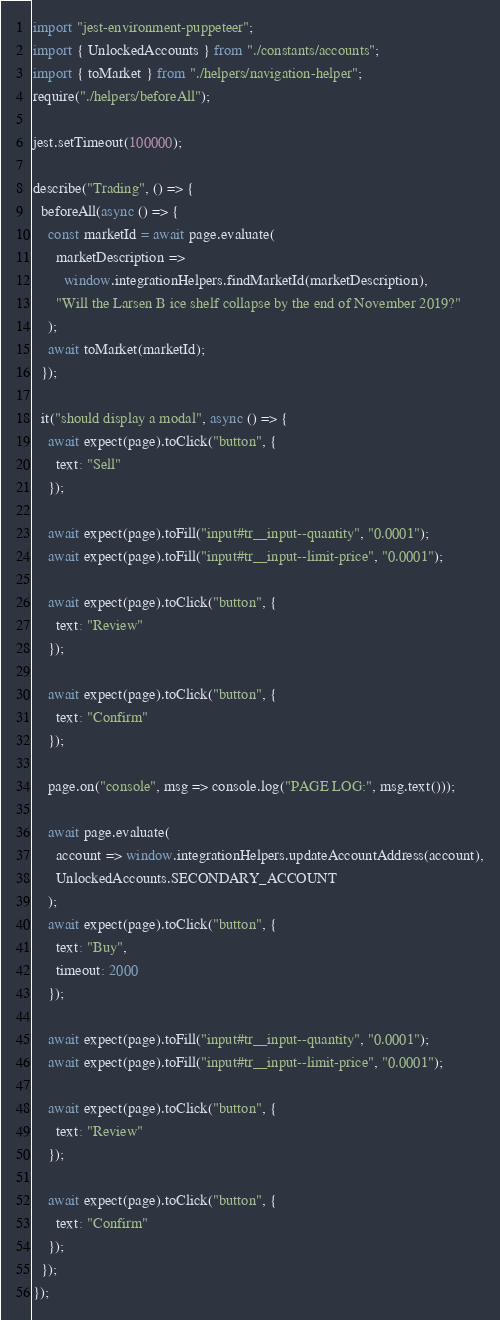<code> <loc_0><loc_0><loc_500><loc_500><_TypeScript_>import "jest-environment-puppeteer";
import { UnlockedAccounts } from "./constants/accounts";
import { toMarket } from "./helpers/navigation-helper";
require("./helpers/beforeAll");

jest.setTimeout(100000);

describe("Trading", () => {
  beforeAll(async () => {
    const marketId = await page.evaluate(
      marketDescription =>
        window.integrationHelpers.findMarketId(marketDescription),
      "Will the Larsen B ice shelf collapse by the end of November 2019?"
    );
    await toMarket(marketId);
  });

  it("should display a modal", async () => {
    await expect(page).toClick("button", {
      text: "Sell"
    });

    await expect(page).toFill("input#tr__input--quantity", "0.0001");
    await expect(page).toFill("input#tr__input--limit-price", "0.0001");

    await expect(page).toClick("button", {
      text: "Review"
    });

    await expect(page).toClick("button", {
      text: "Confirm"
    });

    page.on("console", msg => console.log("PAGE LOG:", msg.text()));

    await page.evaluate(
      account => window.integrationHelpers.updateAccountAddress(account),
      UnlockedAccounts.SECONDARY_ACCOUNT
    );
    await expect(page).toClick("button", {
      text: "Buy",
      timeout: 2000
    });

    await expect(page).toFill("input#tr__input--quantity", "0.0001");
    await expect(page).toFill("input#tr__input--limit-price", "0.0001");

    await expect(page).toClick("button", {
      text: "Review"
    });

    await expect(page).toClick("button", {
      text: "Confirm"
    });
  });
});
</code> 